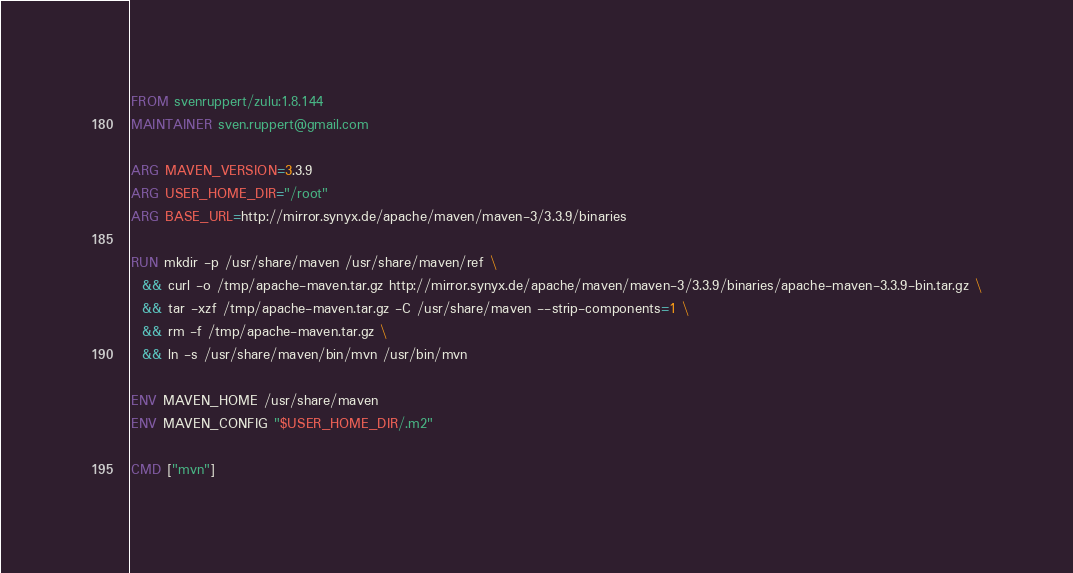Convert code to text. <code><loc_0><loc_0><loc_500><loc_500><_Dockerfile_>FROM svenruppert/zulu:1.8.144
MAINTAINER sven.ruppert@gmail.com

ARG MAVEN_VERSION=3.3.9
ARG USER_HOME_DIR="/root"
ARG BASE_URL=http://mirror.synyx.de/apache/maven/maven-3/3.3.9/binaries

RUN mkdir -p /usr/share/maven /usr/share/maven/ref \
  && curl -o /tmp/apache-maven.tar.gz http://mirror.synyx.de/apache/maven/maven-3/3.3.9/binaries/apache-maven-3.3.9-bin.tar.gz \
  && tar -xzf /tmp/apache-maven.tar.gz -C /usr/share/maven --strip-components=1 \
  && rm -f /tmp/apache-maven.tar.gz \
  && ln -s /usr/share/maven/bin/mvn /usr/bin/mvn

ENV MAVEN_HOME /usr/share/maven
ENV MAVEN_CONFIG "$USER_HOME_DIR/.m2"

CMD ["mvn"]</code> 